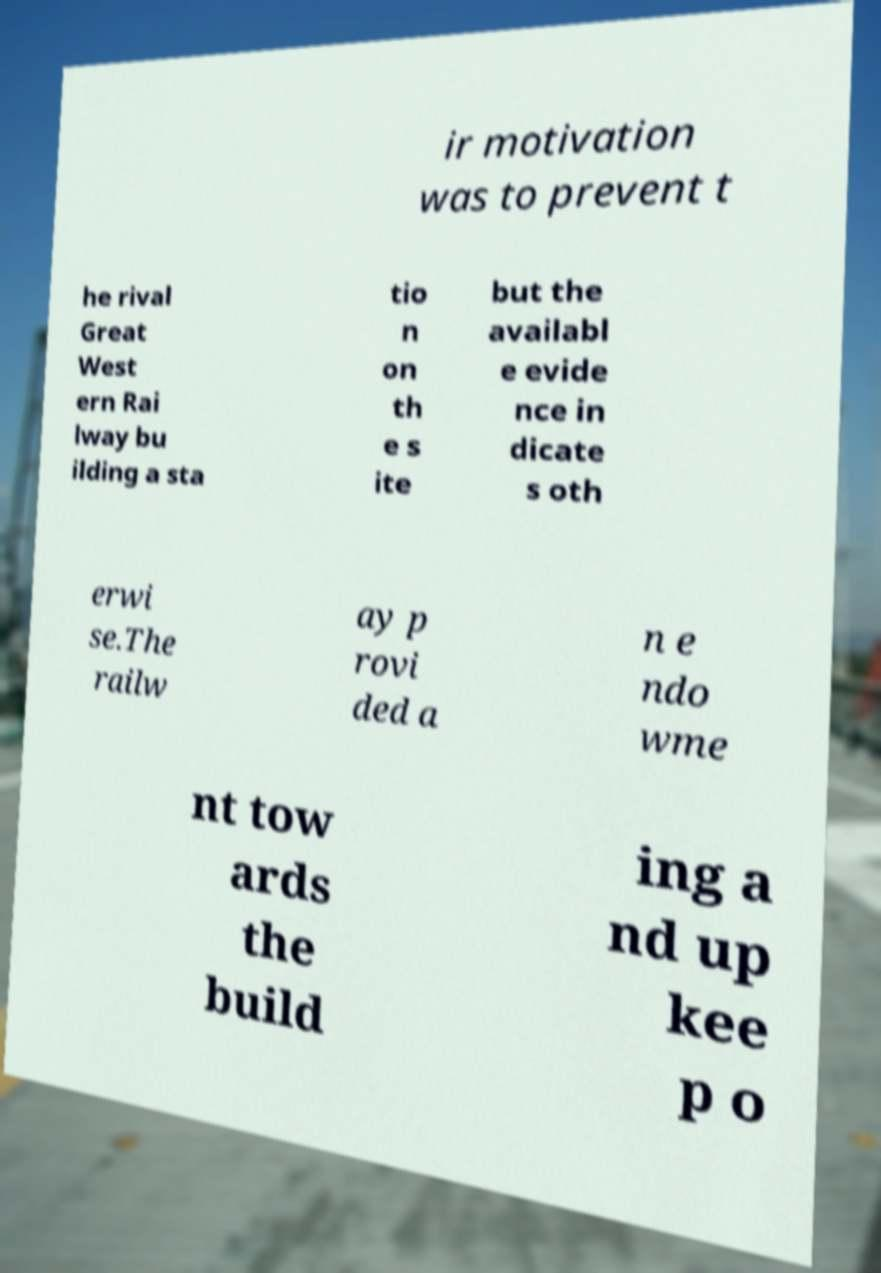Could you extract and type out the text from this image? ir motivation was to prevent t he rival Great West ern Rai lway bu ilding a sta tio n on th e s ite but the availabl e evide nce in dicate s oth erwi se.The railw ay p rovi ded a n e ndo wme nt tow ards the build ing a nd up kee p o 